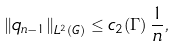Convert formula to latex. <formula><loc_0><loc_0><loc_500><loc_500>\| q _ { n - 1 } \| _ { L ^ { 2 } ( G ) } \leq c _ { 2 } ( \Gamma ) \, \frac { 1 } { n } ,</formula> 